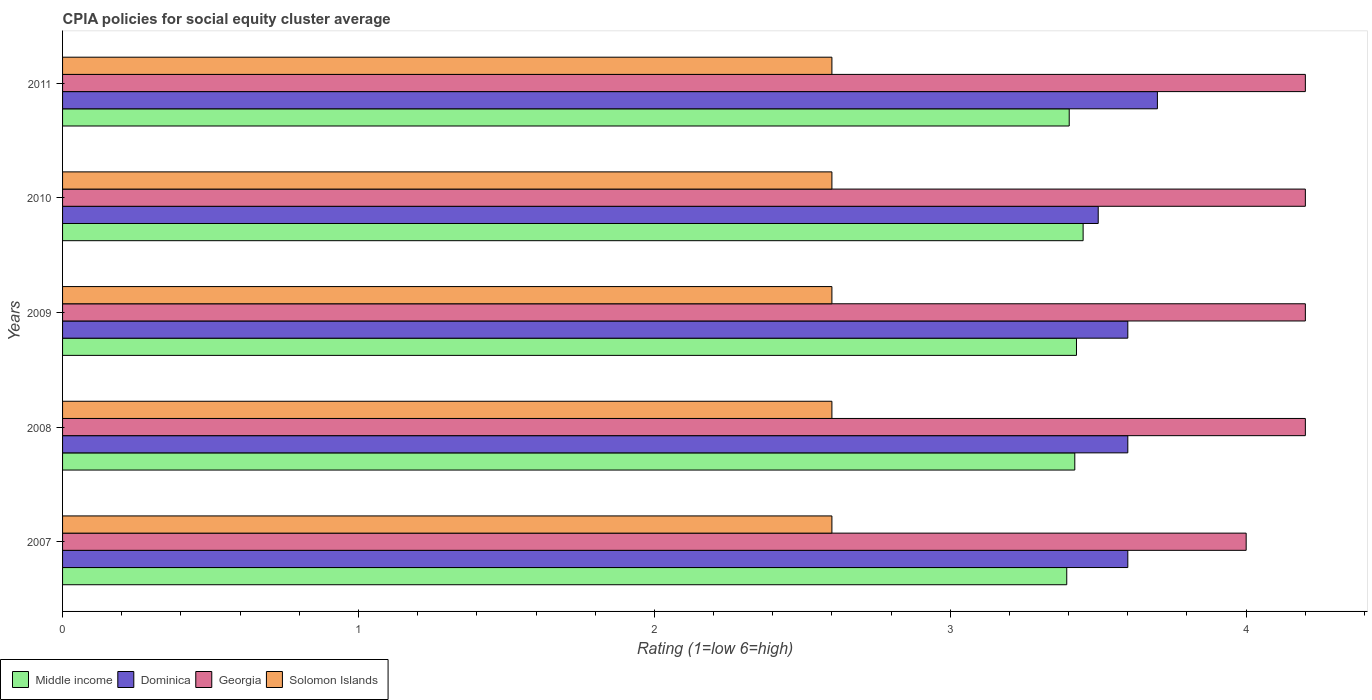How many groups of bars are there?
Provide a succinct answer. 5. Are the number of bars per tick equal to the number of legend labels?
Give a very brief answer. Yes. How many bars are there on the 4th tick from the bottom?
Offer a very short reply. 4. In how many cases, is the number of bars for a given year not equal to the number of legend labels?
Provide a short and direct response. 0. Across all years, what is the maximum CPIA rating in Middle income?
Keep it short and to the point. 3.45. In which year was the CPIA rating in Solomon Islands maximum?
Ensure brevity in your answer.  2007. What is the total CPIA rating in Dominica in the graph?
Provide a succinct answer. 18. What is the difference between the CPIA rating in Middle income in 2010 and the CPIA rating in Dominica in 2008?
Your response must be concise. -0.15. What is the average CPIA rating in Dominica per year?
Keep it short and to the point. 3.6. In the year 2008, what is the difference between the CPIA rating in Georgia and CPIA rating in Middle income?
Offer a terse response. 0.78. What is the ratio of the CPIA rating in Solomon Islands in 2007 to that in 2008?
Your answer should be very brief. 1. Is the difference between the CPIA rating in Georgia in 2008 and 2009 greater than the difference between the CPIA rating in Middle income in 2008 and 2009?
Give a very brief answer. Yes. What is the difference between the highest and the second highest CPIA rating in Georgia?
Keep it short and to the point. 0. What is the difference between the highest and the lowest CPIA rating in Georgia?
Give a very brief answer. 0.2. In how many years, is the CPIA rating in Georgia greater than the average CPIA rating in Georgia taken over all years?
Your answer should be compact. 4. Is it the case that in every year, the sum of the CPIA rating in Georgia and CPIA rating in Solomon Islands is greater than the sum of CPIA rating in Middle income and CPIA rating in Dominica?
Your answer should be very brief. No. What does the 4th bar from the bottom in 2009 represents?
Make the answer very short. Solomon Islands. How many bars are there?
Keep it short and to the point. 20. How many legend labels are there?
Your answer should be compact. 4. How are the legend labels stacked?
Offer a very short reply. Horizontal. What is the title of the graph?
Offer a terse response. CPIA policies for social equity cluster average. What is the Rating (1=low 6=high) of Middle income in 2007?
Give a very brief answer. 3.39. What is the Rating (1=low 6=high) of Middle income in 2008?
Provide a succinct answer. 3.42. What is the Rating (1=low 6=high) in Middle income in 2009?
Your response must be concise. 3.43. What is the Rating (1=low 6=high) in Dominica in 2009?
Make the answer very short. 3.6. What is the Rating (1=low 6=high) of Solomon Islands in 2009?
Offer a terse response. 2.6. What is the Rating (1=low 6=high) of Middle income in 2010?
Provide a short and direct response. 3.45. What is the Rating (1=low 6=high) in Georgia in 2010?
Offer a very short reply. 4.2. What is the Rating (1=low 6=high) in Middle income in 2011?
Give a very brief answer. 3.4. What is the Rating (1=low 6=high) in Dominica in 2011?
Ensure brevity in your answer.  3.7. What is the Rating (1=low 6=high) of Solomon Islands in 2011?
Provide a short and direct response. 2.6. Across all years, what is the maximum Rating (1=low 6=high) of Middle income?
Offer a terse response. 3.45. Across all years, what is the maximum Rating (1=low 6=high) in Dominica?
Provide a succinct answer. 3.7. Across all years, what is the maximum Rating (1=low 6=high) of Solomon Islands?
Provide a short and direct response. 2.6. Across all years, what is the minimum Rating (1=low 6=high) in Middle income?
Give a very brief answer. 3.39. Across all years, what is the minimum Rating (1=low 6=high) in Dominica?
Offer a very short reply. 3.5. Across all years, what is the minimum Rating (1=low 6=high) of Georgia?
Your answer should be compact. 4. Across all years, what is the minimum Rating (1=low 6=high) of Solomon Islands?
Your answer should be compact. 2.6. What is the total Rating (1=low 6=high) in Middle income in the graph?
Keep it short and to the point. 17.09. What is the total Rating (1=low 6=high) of Dominica in the graph?
Give a very brief answer. 18. What is the total Rating (1=low 6=high) of Georgia in the graph?
Provide a short and direct response. 20.8. What is the difference between the Rating (1=low 6=high) of Middle income in 2007 and that in 2008?
Offer a very short reply. -0.03. What is the difference between the Rating (1=low 6=high) of Dominica in 2007 and that in 2008?
Your answer should be compact. 0. What is the difference between the Rating (1=low 6=high) in Solomon Islands in 2007 and that in 2008?
Offer a terse response. 0. What is the difference between the Rating (1=low 6=high) of Middle income in 2007 and that in 2009?
Offer a terse response. -0.03. What is the difference between the Rating (1=low 6=high) of Dominica in 2007 and that in 2009?
Make the answer very short. 0. What is the difference between the Rating (1=low 6=high) of Solomon Islands in 2007 and that in 2009?
Offer a very short reply. 0. What is the difference between the Rating (1=low 6=high) of Middle income in 2007 and that in 2010?
Provide a succinct answer. -0.06. What is the difference between the Rating (1=low 6=high) of Georgia in 2007 and that in 2010?
Your answer should be compact. -0.2. What is the difference between the Rating (1=low 6=high) in Middle income in 2007 and that in 2011?
Offer a terse response. -0.01. What is the difference between the Rating (1=low 6=high) in Dominica in 2007 and that in 2011?
Keep it short and to the point. -0.1. What is the difference between the Rating (1=low 6=high) of Solomon Islands in 2007 and that in 2011?
Provide a short and direct response. 0. What is the difference between the Rating (1=low 6=high) in Middle income in 2008 and that in 2009?
Make the answer very short. -0.01. What is the difference between the Rating (1=low 6=high) in Dominica in 2008 and that in 2009?
Ensure brevity in your answer.  0. What is the difference between the Rating (1=low 6=high) in Middle income in 2008 and that in 2010?
Your answer should be compact. -0.03. What is the difference between the Rating (1=low 6=high) of Dominica in 2008 and that in 2010?
Offer a very short reply. 0.1. What is the difference between the Rating (1=low 6=high) of Solomon Islands in 2008 and that in 2010?
Make the answer very short. 0. What is the difference between the Rating (1=low 6=high) in Middle income in 2008 and that in 2011?
Offer a very short reply. 0.02. What is the difference between the Rating (1=low 6=high) in Dominica in 2008 and that in 2011?
Keep it short and to the point. -0.1. What is the difference between the Rating (1=low 6=high) in Solomon Islands in 2008 and that in 2011?
Offer a terse response. 0. What is the difference between the Rating (1=low 6=high) in Middle income in 2009 and that in 2010?
Ensure brevity in your answer.  -0.02. What is the difference between the Rating (1=low 6=high) of Solomon Islands in 2009 and that in 2010?
Your response must be concise. 0. What is the difference between the Rating (1=low 6=high) in Middle income in 2009 and that in 2011?
Make the answer very short. 0.02. What is the difference between the Rating (1=low 6=high) in Middle income in 2010 and that in 2011?
Provide a succinct answer. 0.05. What is the difference between the Rating (1=low 6=high) in Dominica in 2010 and that in 2011?
Your response must be concise. -0.2. What is the difference between the Rating (1=low 6=high) of Georgia in 2010 and that in 2011?
Your response must be concise. 0. What is the difference between the Rating (1=low 6=high) of Solomon Islands in 2010 and that in 2011?
Keep it short and to the point. 0. What is the difference between the Rating (1=low 6=high) of Middle income in 2007 and the Rating (1=low 6=high) of Dominica in 2008?
Provide a short and direct response. -0.21. What is the difference between the Rating (1=low 6=high) in Middle income in 2007 and the Rating (1=low 6=high) in Georgia in 2008?
Your answer should be very brief. -0.81. What is the difference between the Rating (1=low 6=high) in Middle income in 2007 and the Rating (1=low 6=high) in Solomon Islands in 2008?
Offer a very short reply. 0.79. What is the difference between the Rating (1=low 6=high) of Georgia in 2007 and the Rating (1=low 6=high) of Solomon Islands in 2008?
Your answer should be very brief. 1.4. What is the difference between the Rating (1=low 6=high) of Middle income in 2007 and the Rating (1=low 6=high) of Dominica in 2009?
Your response must be concise. -0.21. What is the difference between the Rating (1=low 6=high) of Middle income in 2007 and the Rating (1=low 6=high) of Georgia in 2009?
Offer a terse response. -0.81. What is the difference between the Rating (1=low 6=high) of Middle income in 2007 and the Rating (1=low 6=high) of Solomon Islands in 2009?
Provide a succinct answer. 0.79. What is the difference between the Rating (1=low 6=high) in Dominica in 2007 and the Rating (1=low 6=high) in Solomon Islands in 2009?
Your answer should be very brief. 1. What is the difference between the Rating (1=low 6=high) in Georgia in 2007 and the Rating (1=low 6=high) in Solomon Islands in 2009?
Offer a very short reply. 1.4. What is the difference between the Rating (1=low 6=high) in Middle income in 2007 and the Rating (1=low 6=high) in Dominica in 2010?
Provide a short and direct response. -0.11. What is the difference between the Rating (1=low 6=high) of Middle income in 2007 and the Rating (1=low 6=high) of Georgia in 2010?
Provide a short and direct response. -0.81. What is the difference between the Rating (1=low 6=high) of Middle income in 2007 and the Rating (1=low 6=high) of Solomon Islands in 2010?
Make the answer very short. 0.79. What is the difference between the Rating (1=low 6=high) of Dominica in 2007 and the Rating (1=low 6=high) of Georgia in 2010?
Your answer should be very brief. -0.6. What is the difference between the Rating (1=low 6=high) of Dominica in 2007 and the Rating (1=low 6=high) of Solomon Islands in 2010?
Keep it short and to the point. 1. What is the difference between the Rating (1=low 6=high) of Middle income in 2007 and the Rating (1=low 6=high) of Dominica in 2011?
Offer a very short reply. -0.31. What is the difference between the Rating (1=low 6=high) of Middle income in 2007 and the Rating (1=low 6=high) of Georgia in 2011?
Your response must be concise. -0.81. What is the difference between the Rating (1=low 6=high) of Middle income in 2007 and the Rating (1=low 6=high) of Solomon Islands in 2011?
Keep it short and to the point. 0.79. What is the difference between the Rating (1=low 6=high) in Dominica in 2007 and the Rating (1=low 6=high) in Georgia in 2011?
Make the answer very short. -0.6. What is the difference between the Rating (1=low 6=high) of Georgia in 2007 and the Rating (1=low 6=high) of Solomon Islands in 2011?
Provide a short and direct response. 1.4. What is the difference between the Rating (1=low 6=high) of Middle income in 2008 and the Rating (1=low 6=high) of Dominica in 2009?
Provide a succinct answer. -0.18. What is the difference between the Rating (1=low 6=high) of Middle income in 2008 and the Rating (1=low 6=high) of Georgia in 2009?
Your response must be concise. -0.78. What is the difference between the Rating (1=low 6=high) in Middle income in 2008 and the Rating (1=low 6=high) in Solomon Islands in 2009?
Your answer should be very brief. 0.82. What is the difference between the Rating (1=low 6=high) of Georgia in 2008 and the Rating (1=low 6=high) of Solomon Islands in 2009?
Your response must be concise. 1.6. What is the difference between the Rating (1=low 6=high) of Middle income in 2008 and the Rating (1=low 6=high) of Dominica in 2010?
Provide a succinct answer. -0.08. What is the difference between the Rating (1=low 6=high) in Middle income in 2008 and the Rating (1=low 6=high) in Georgia in 2010?
Provide a succinct answer. -0.78. What is the difference between the Rating (1=low 6=high) of Middle income in 2008 and the Rating (1=low 6=high) of Solomon Islands in 2010?
Provide a short and direct response. 0.82. What is the difference between the Rating (1=low 6=high) in Georgia in 2008 and the Rating (1=low 6=high) in Solomon Islands in 2010?
Offer a terse response. 1.6. What is the difference between the Rating (1=low 6=high) in Middle income in 2008 and the Rating (1=low 6=high) in Dominica in 2011?
Give a very brief answer. -0.28. What is the difference between the Rating (1=low 6=high) of Middle income in 2008 and the Rating (1=low 6=high) of Georgia in 2011?
Provide a succinct answer. -0.78. What is the difference between the Rating (1=low 6=high) in Middle income in 2008 and the Rating (1=low 6=high) in Solomon Islands in 2011?
Provide a succinct answer. 0.82. What is the difference between the Rating (1=low 6=high) in Dominica in 2008 and the Rating (1=low 6=high) in Georgia in 2011?
Give a very brief answer. -0.6. What is the difference between the Rating (1=low 6=high) in Georgia in 2008 and the Rating (1=low 6=high) in Solomon Islands in 2011?
Your answer should be very brief. 1.6. What is the difference between the Rating (1=low 6=high) in Middle income in 2009 and the Rating (1=low 6=high) in Dominica in 2010?
Make the answer very short. -0.07. What is the difference between the Rating (1=low 6=high) of Middle income in 2009 and the Rating (1=low 6=high) of Georgia in 2010?
Offer a terse response. -0.77. What is the difference between the Rating (1=low 6=high) of Middle income in 2009 and the Rating (1=low 6=high) of Solomon Islands in 2010?
Make the answer very short. 0.83. What is the difference between the Rating (1=low 6=high) of Middle income in 2009 and the Rating (1=low 6=high) of Dominica in 2011?
Give a very brief answer. -0.27. What is the difference between the Rating (1=low 6=high) of Middle income in 2009 and the Rating (1=low 6=high) of Georgia in 2011?
Provide a succinct answer. -0.77. What is the difference between the Rating (1=low 6=high) of Middle income in 2009 and the Rating (1=low 6=high) of Solomon Islands in 2011?
Keep it short and to the point. 0.83. What is the difference between the Rating (1=low 6=high) of Dominica in 2009 and the Rating (1=low 6=high) of Solomon Islands in 2011?
Your answer should be compact. 1. What is the difference between the Rating (1=low 6=high) in Middle income in 2010 and the Rating (1=low 6=high) in Dominica in 2011?
Your answer should be compact. -0.25. What is the difference between the Rating (1=low 6=high) of Middle income in 2010 and the Rating (1=low 6=high) of Georgia in 2011?
Your answer should be compact. -0.75. What is the difference between the Rating (1=low 6=high) of Middle income in 2010 and the Rating (1=low 6=high) of Solomon Islands in 2011?
Make the answer very short. 0.85. What is the difference between the Rating (1=low 6=high) in Dominica in 2010 and the Rating (1=low 6=high) in Georgia in 2011?
Your response must be concise. -0.7. What is the average Rating (1=low 6=high) of Middle income per year?
Make the answer very short. 3.42. What is the average Rating (1=low 6=high) of Georgia per year?
Offer a terse response. 4.16. In the year 2007, what is the difference between the Rating (1=low 6=high) of Middle income and Rating (1=low 6=high) of Dominica?
Your answer should be compact. -0.21. In the year 2007, what is the difference between the Rating (1=low 6=high) of Middle income and Rating (1=low 6=high) of Georgia?
Ensure brevity in your answer.  -0.61. In the year 2007, what is the difference between the Rating (1=low 6=high) of Middle income and Rating (1=low 6=high) of Solomon Islands?
Provide a succinct answer. 0.79. In the year 2007, what is the difference between the Rating (1=low 6=high) of Dominica and Rating (1=low 6=high) of Georgia?
Provide a succinct answer. -0.4. In the year 2007, what is the difference between the Rating (1=low 6=high) in Georgia and Rating (1=low 6=high) in Solomon Islands?
Provide a short and direct response. 1.4. In the year 2008, what is the difference between the Rating (1=low 6=high) in Middle income and Rating (1=low 6=high) in Dominica?
Keep it short and to the point. -0.18. In the year 2008, what is the difference between the Rating (1=low 6=high) in Middle income and Rating (1=low 6=high) in Georgia?
Offer a terse response. -0.78. In the year 2008, what is the difference between the Rating (1=low 6=high) of Middle income and Rating (1=low 6=high) of Solomon Islands?
Provide a succinct answer. 0.82. In the year 2008, what is the difference between the Rating (1=low 6=high) in Dominica and Rating (1=low 6=high) in Georgia?
Make the answer very short. -0.6. In the year 2008, what is the difference between the Rating (1=low 6=high) of Dominica and Rating (1=low 6=high) of Solomon Islands?
Give a very brief answer. 1. In the year 2008, what is the difference between the Rating (1=low 6=high) of Georgia and Rating (1=low 6=high) of Solomon Islands?
Keep it short and to the point. 1.6. In the year 2009, what is the difference between the Rating (1=low 6=high) in Middle income and Rating (1=low 6=high) in Dominica?
Keep it short and to the point. -0.17. In the year 2009, what is the difference between the Rating (1=low 6=high) in Middle income and Rating (1=low 6=high) in Georgia?
Your answer should be very brief. -0.77. In the year 2009, what is the difference between the Rating (1=low 6=high) of Middle income and Rating (1=low 6=high) of Solomon Islands?
Your answer should be compact. 0.83. In the year 2009, what is the difference between the Rating (1=low 6=high) in Dominica and Rating (1=low 6=high) in Georgia?
Provide a short and direct response. -0.6. In the year 2009, what is the difference between the Rating (1=low 6=high) in Georgia and Rating (1=low 6=high) in Solomon Islands?
Give a very brief answer. 1.6. In the year 2010, what is the difference between the Rating (1=low 6=high) in Middle income and Rating (1=low 6=high) in Dominica?
Your answer should be compact. -0.05. In the year 2010, what is the difference between the Rating (1=low 6=high) of Middle income and Rating (1=low 6=high) of Georgia?
Give a very brief answer. -0.75. In the year 2010, what is the difference between the Rating (1=low 6=high) in Middle income and Rating (1=low 6=high) in Solomon Islands?
Your response must be concise. 0.85. In the year 2010, what is the difference between the Rating (1=low 6=high) in Dominica and Rating (1=low 6=high) in Georgia?
Provide a short and direct response. -0.7. In the year 2010, what is the difference between the Rating (1=low 6=high) in Dominica and Rating (1=low 6=high) in Solomon Islands?
Your answer should be compact. 0.9. In the year 2010, what is the difference between the Rating (1=low 6=high) in Georgia and Rating (1=low 6=high) in Solomon Islands?
Your answer should be very brief. 1.6. In the year 2011, what is the difference between the Rating (1=low 6=high) of Middle income and Rating (1=low 6=high) of Dominica?
Offer a terse response. -0.3. In the year 2011, what is the difference between the Rating (1=low 6=high) of Middle income and Rating (1=low 6=high) of Georgia?
Your answer should be compact. -0.8. In the year 2011, what is the difference between the Rating (1=low 6=high) of Middle income and Rating (1=low 6=high) of Solomon Islands?
Offer a very short reply. 0.8. In the year 2011, what is the difference between the Rating (1=low 6=high) in Dominica and Rating (1=low 6=high) in Solomon Islands?
Your answer should be compact. 1.1. What is the ratio of the Rating (1=low 6=high) of Middle income in 2007 to that in 2008?
Your answer should be compact. 0.99. What is the ratio of the Rating (1=low 6=high) in Dominica in 2007 to that in 2008?
Your answer should be very brief. 1. What is the ratio of the Rating (1=low 6=high) in Georgia in 2007 to that in 2009?
Ensure brevity in your answer.  0.95. What is the ratio of the Rating (1=low 6=high) of Solomon Islands in 2007 to that in 2009?
Your answer should be compact. 1. What is the ratio of the Rating (1=low 6=high) of Middle income in 2007 to that in 2010?
Your answer should be very brief. 0.98. What is the ratio of the Rating (1=low 6=high) of Dominica in 2007 to that in 2010?
Make the answer very short. 1.03. What is the ratio of the Rating (1=low 6=high) of Solomon Islands in 2007 to that in 2010?
Your answer should be very brief. 1. What is the ratio of the Rating (1=low 6=high) in Dominica in 2008 to that in 2010?
Offer a very short reply. 1.03. What is the ratio of the Rating (1=low 6=high) in Georgia in 2008 to that in 2010?
Provide a short and direct response. 1. What is the ratio of the Rating (1=low 6=high) in Middle income in 2008 to that in 2011?
Keep it short and to the point. 1.01. What is the ratio of the Rating (1=low 6=high) of Dominica in 2008 to that in 2011?
Offer a very short reply. 0.97. What is the ratio of the Rating (1=low 6=high) in Georgia in 2008 to that in 2011?
Your response must be concise. 1. What is the ratio of the Rating (1=low 6=high) in Solomon Islands in 2008 to that in 2011?
Provide a succinct answer. 1. What is the ratio of the Rating (1=low 6=high) of Dominica in 2009 to that in 2010?
Offer a very short reply. 1.03. What is the ratio of the Rating (1=low 6=high) in Dominica in 2009 to that in 2011?
Your answer should be very brief. 0.97. What is the ratio of the Rating (1=low 6=high) of Middle income in 2010 to that in 2011?
Your response must be concise. 1.01. What is the ratio of the Rating (1=low 6=high) in Dominica in 2010 to that in 2011?
Ensure brevity in your answer.  0.95. What is the difference between the highest and the second highest Rating (1=low 6=high) of Middle income?
Ensure brevity in your answer.  0.02. What is the difference between the highest and the second highest Rating (1=low 6=high) in Dominica?
Provide a succinct answer. 0.1. What is the difference between the highest and the second highest Rating (1=low 6=high) in Georgia?
Give a very brief answer. 0. What is the difference between the highest and the second highest Rating (1=low 6=high) in Solomon Islands?
Your answer should be compact. 0. What is the difference between the highest and the lowest Rating (1=low 6=high) of Middle income?
Keep it short and to the point. 0.06. What is the difference between the highest and the lowest Rating (1=low 6=high) of Dominica?
Give a very brief answer. 0.2. 